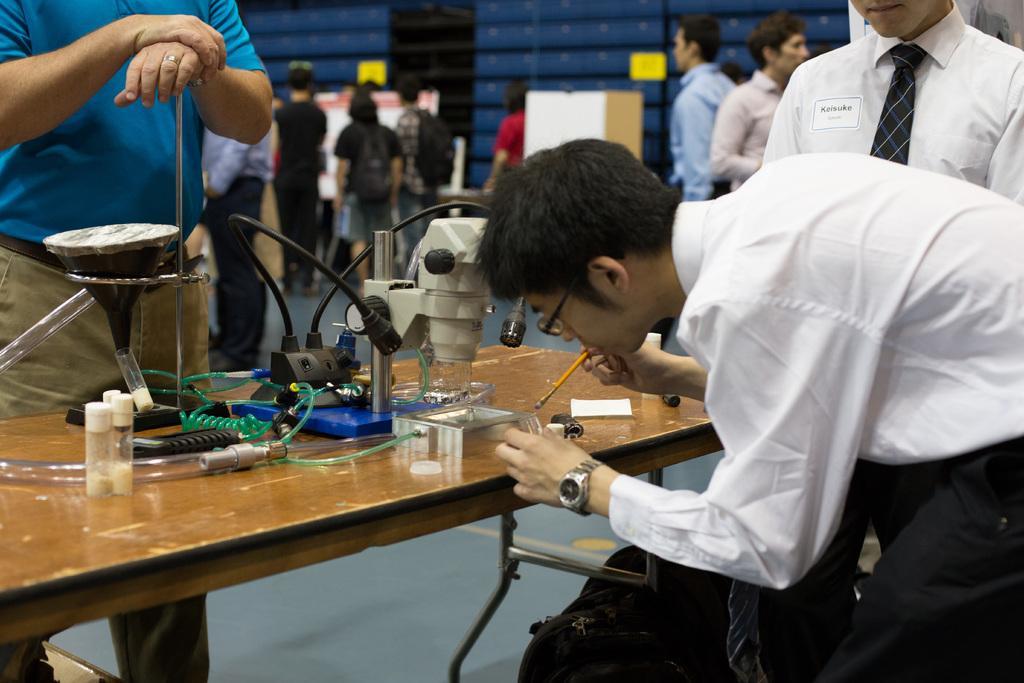In one or two sentences, can you explain what this image depicts? In this image two persons are at the right side of the image are wearing white shirt. A person who is bent towards the table is wearing a watch and spectacles. Person behind to him is wearing a tie at the left side there is a person standing and keeping his hand on the rod is wearing a blue shirt. On the table there is a micro scope, few thin bottles and wires are kept on the table. At the background there are few persons in this image. 